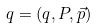<formula> <loc_0><loc_0><loc_500><loc_500>q = ( q , P , \vec { p } )</formula> 